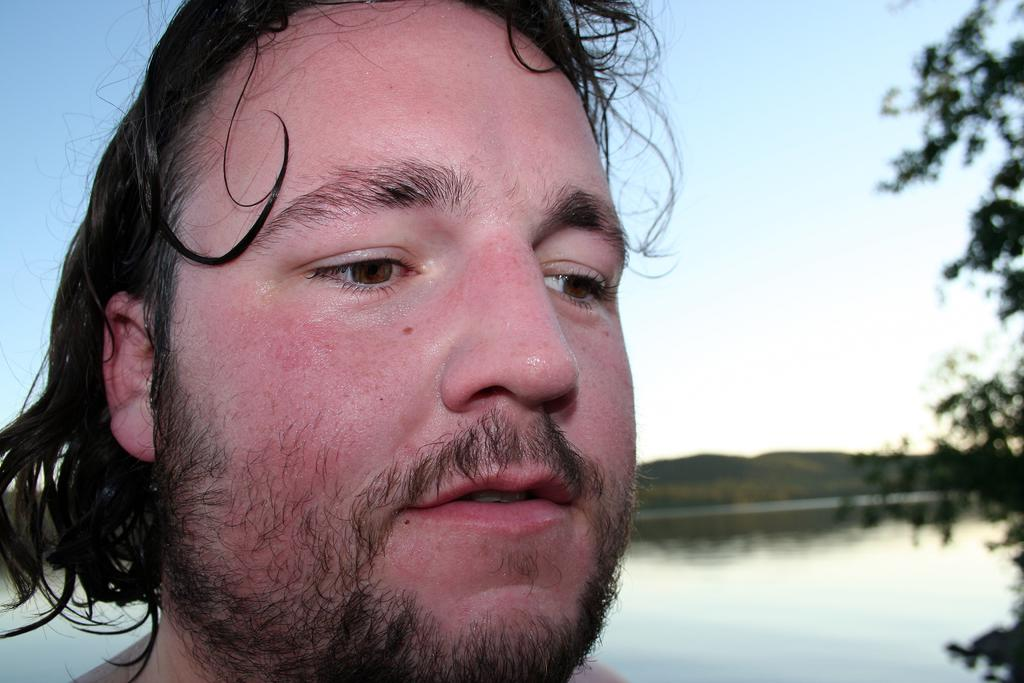What is the main subject in the foreground of the image? There is a person in the foreground of the image. What can be seen in the background of the image? There are mountains, the sky, and water visible in the background of the image. Where is the tree located in the image? There is a tree on the right side of the image. What type of club is the bear holding in the image? There is no bear or club present in the image. 